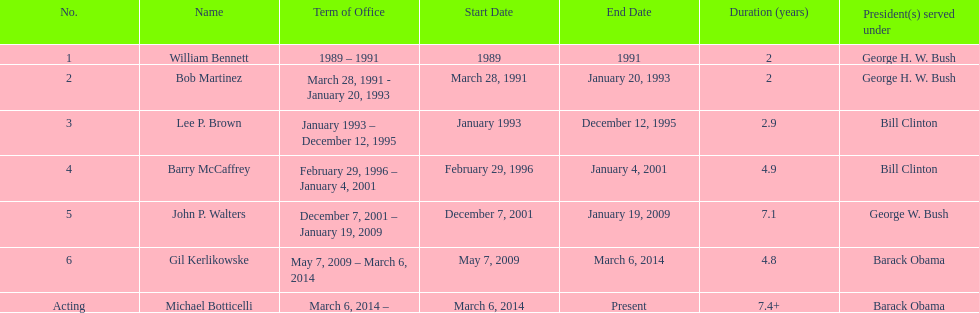What were the total number of years bob martinez served in office? 2. 